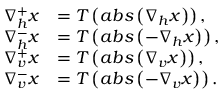<formula> <loc_0><loc_0><loc_500><loc_500>\begin{array} { r l } { \nabla _ { h } ^ { + } x } & { = T \left ( a b s \left ( \nabla _ { h } x \right ) \right ) , } \\ { \nabla _ { h } ^ { - } x } & { = T \left ( a b s \left ( - \nabla _ { h } x \right ) \right ) , } \\ { \nabla _ { v } ^ { + } x } & { = T \left ( a b s \left ( \nabla _ { v } x \right ) \right ) , } \\ { \nabla _ { v } ^ { - } x } & { = T \left ( a b s \left ( - \nabla _ { v } x \right ) \right ) . } \end{array}</formula> 